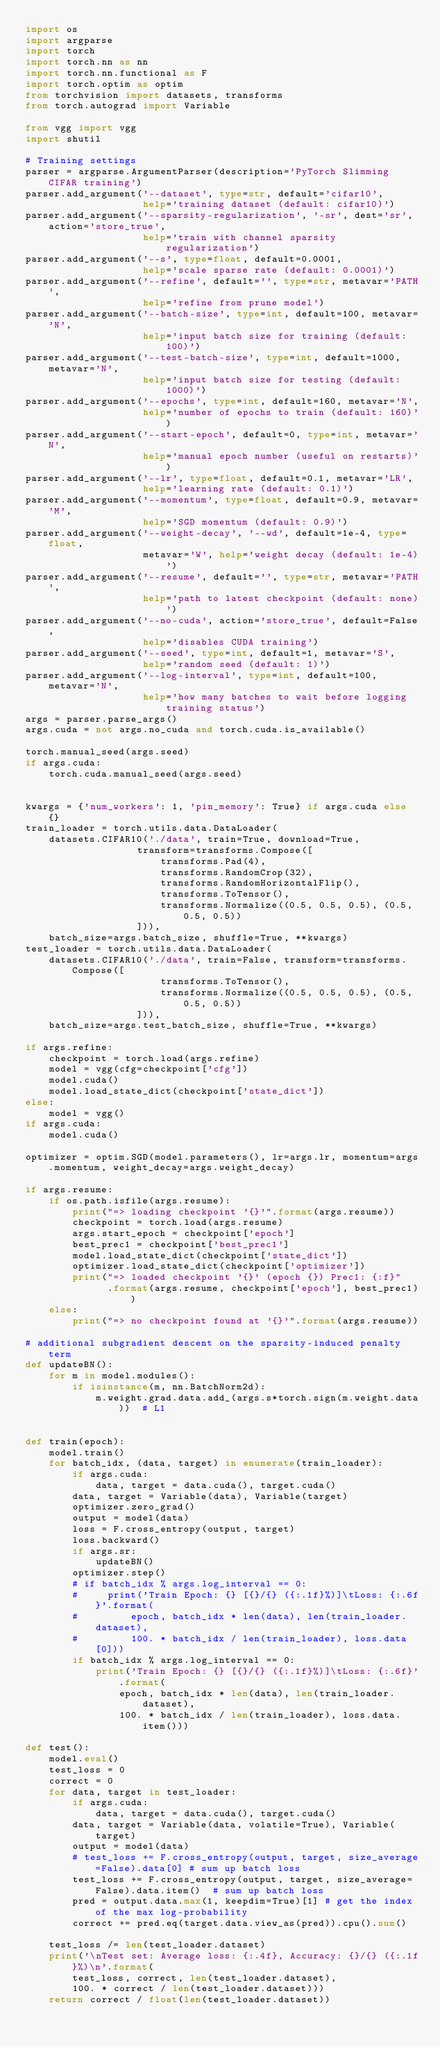<code> <loc_0><loc_0><loc_500><loc_500><_Python_>import os
import argparse
import torch
import torch.nn as nn
import torch.nn.functional as F
import torch.optim as optim
from torchvision import datasets, transforms
from torch.autograd import Variable

from vgg import vgg
import shutil

# Training settings
parser = argparse.ArgumentParser(description='PyTorch Slimming CIFAR training')
parser.add_argument('--dataset', type=str, default='cifar10',
                    help='training dataset (default: cifar10)')
parser.add_argument('--sparsity-regularization', '-sr', dest='sr', action='store_true',
                    help='train with channel sparsity regularization')
parser.add_argument('--s', type=float, default=0.0001,
                    help='scale sparse rate (default: 0.0001)')
parser.add_argument('--refine', default='', type=str, metavar='PATH',
                    help='refine from prune model')
parser.add_argument('--batch-size', type=int, default=100, metavar='N',
                    help='input batch size for training (default: 100)')
parser.add_argument('--test-batch-size', type=int, default=1000, metavar='N',
                    help='input batch size for testing (default: 1000)')
parser.add_argument('--epochs', type=int, default=160, metavar='N',
                    help='number of epochs to train (default: 160)')
parser.add_argument('--start-epoch', default=0, type=int, metavar='N',
                    help='manual epoch number (useful on restarts)')
parser.add_argument('--lr', type=float, default=0.1, metavar='LR',
                    help='learning rate (default: 0.1)')
parser.add_argument('--momentum', type=float, default=0.9, metavar='M',
                    help='SGD momentum (default: 0.9)')
parser.add_argument('--weight-decay', '--wd', default=1e-4, type=float,
                    metavar='W', help='weight decay (default: 1e-4)')
parser.add_argument('--resume', default='', type=str, metavar='PATH',
                    help='path to latest checkpoint (default: none)')
parser.add_argument('--no-cuda', action='store_true', default=False,
                    help='disables CUDA training')
parser.add_argument('--seed', type=int, default=1, metavar='S',
                    help='random seed (default: 1)')
parser.add_argument('--log-interval', type=int, default=100, metavar='N',
                    help='how many batches to wait before logging training status')
args = parser.parse_args()
args.cuda = not args.no_cuda and torch.cuda.is_available()

torch.manual_seed(args.seed)
if args.cuda:
    torch.cuda.manual_seed(args.seed)


kwargs = {'num_workers': 1, 'pin_memory': True} if args.cuda else {}
train_loader = torch.utils.data.DataLoader(
    datasets.CIFAR10('./data', train=True, download=True,
                   transform=transforms.Compose([
                       transforms.Pad(4),
                       transforms.RandomCrop(32),
                       transforms.RandomHorizontalFlip(),
                       transforms.ToTensor(),
                       transforms.Normalize((0.5, 0.5, 0.5), (0.5, 0.5, 0.5))
                   ])),
    batch_size=args.batch_size, shuffle=True, **kwargs)
test_loader = torch.utils.data.DataLoader(
    datasets.CIFAR10('./data', train=False, transform=transforms.Compose([
                       transforms.ToTensor(),
                       transforms.Normalize((0.5, 0.5, 0.5), (0.5, 0.5, 0.5))
                   ])),
    batch_size=args.test_batch_size, shuffle=True, **kwargs)

if args.refine:
    checkpoint = torch.load(args.refine)
    model = vgg(cfg=checkpoint['cfg'])
    model.cuda()
    model.load_state_dict(checkpoint['state_dict'])
else:
    model = vgg()
if args.cuda:
    model.cuda()

optimizer = optim.SGD(model.parameters(), lr=args.lr, momentum=args.momentum, weight_decay=args.weight_decay)

if args.resume:
    if os.path.isfile(args.resume):
        print("=> loading checkpoint '{}'".format(args.resume))
        checkpoint = torch.load(args.resume)
        args.start_epoch = checkpoint['epoch']
        best_prec1 = checkpoint['best_prec1']
        model.load_state_dict(checkpoint['state_dict'])
        optimizer.load_state_dict(checkpoint['optimizer'])
        print("=> loaded checkpoint '{}' (epoch {}) Prec1: {:f}"
              .format(args.resume, checkpoint['epoch'], best_prec1))
    else:
        print("=> no checkpoint found at '{}'".format(args.resume))

# additional subgradient descent on the sparsity-induced penalty term
def updateBN():
    for m in model.modules():
        if isinstance(m, nn.BatchNorm2d):
            m.weight.grad.data.add_(args.s*torch.sign(m.weight.data))  # L1


def train(epoch):
    model.train()
    for batch_idx, (data, target) in enumerate(train_loader):
        if args.cuda:
            data, target = data.cuda(), target.cuda()
        data, target = Variable(data), Variable(target)
        optimizer.zero_grad()
        output = model(data)
        loss = F.cross_entropy(output, target)
        loss.backward()
        if args.sr:
            updateBN()
        optimizer.step()
        # if batch_idx % args.log_interval == 0:
        #     print('Train Epoch: {} [{}/{} ({:.1f}%)]\tLoss: {:.6f}'.format(
        #         epoch, batch_idx * len(data), len(train_loader.dataset),
        #         100. * batch_idx / len(train_loader), loss.data[0]))
        if batch_idx % args.log_interval == 0:
            print('Train Epoch: {} [{}/{} ({:.1f}%)]\tLoss: {:.6f}'.format(
                epoch, batch_idx * len(data), len(train_loader.dataset),
                100. * batch_idx / len(train_loader), loss.data.item()))

def test():
    model.eval()
    test_loss = 0
    correct = 0
    for data, target in test_loader:
        if args.cuda:
            data, target = data.cuda(), target.cuda()
        data, target = Variable(data, volatile=True), Variable(target)
        output = model(data)
        # test_loss += F.cross_entropy(output, target, size_average=False).data[0] # sum up batch loss
        test_loss += F.cross_entropy(output, target, size_average=False).data.item()  # sum up batch loss
        pred = output.data.max(1, keepdim=True)[1] # get the index of the max log-probability
        correct += pred.eq(target.data.view_as(pred)).cpu().sum()

    test_loss /= len(test_loader.dataset)
    print('\nTest set: Average loss: {:.4f}, Accuracy: {}/{} ({:.1f}%)\n'.format(
        test_loss, correct, len(test_loader.dataset),
        100. * correct / len(test_loader.dataset)))
    return correct / float(len(test_loader.dataset))

</code> 